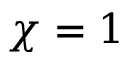Convert formula to latex. <formula><loc_0><loc_0><loc_500><loc_500>\chi = 1</formula> 